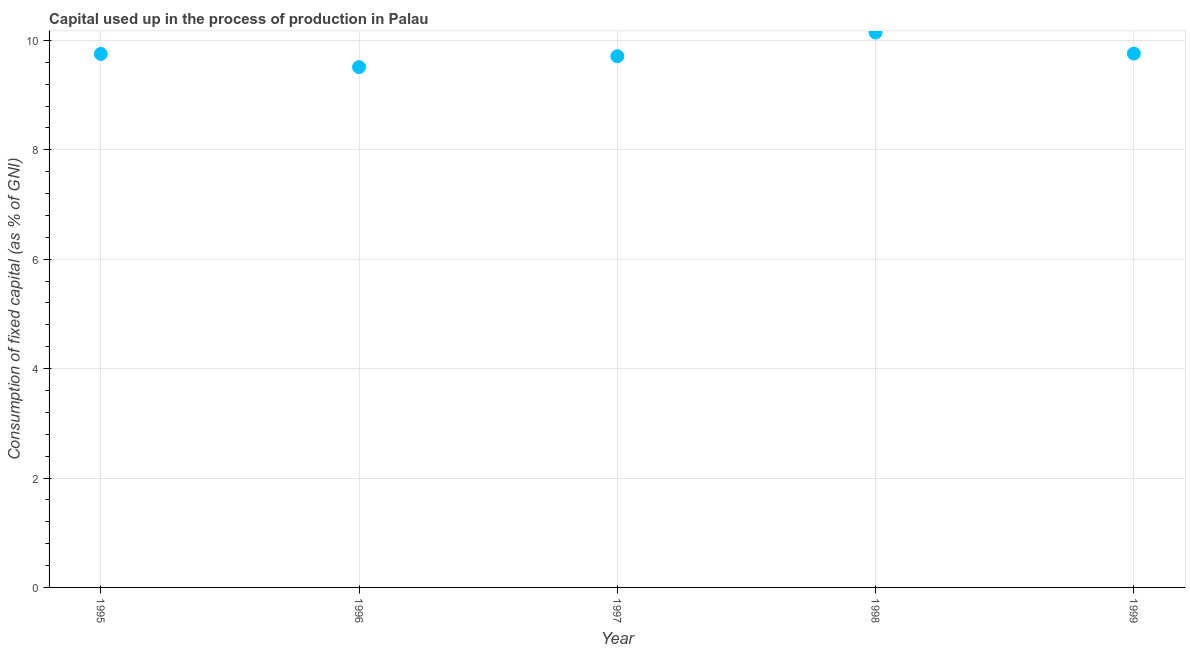What is the consumption of fixed capital in 1997?
Your response must be concise. 9.71. Across all years, what is the maximum consumption of fixed capital?
Your answer should be very brief. 10.14. Across all years, what is the minimum consumption of fixed capital?
Provide a short and direct response. 9.51. In which year was the consumption of fixed capital minimum?
Your answer should be very brief. 1996. What is the sum of the consumption of fixed capital?
Keep it short and to the point. 48.87. What is the difference between the consumption of fixed capital in 1995 and 1999?
Give a very brief answer. -0.01. What is the average consumption of fixed capital per year?
Offer a very short reply. 9.77. What is the median consumption of fixed capital?
Offer a terse response. 9.75. In how many years, is the consumption of fixed capital greater than 8.8 %?
Provide a succinct answer. 5. What is the ratio of the consumption of fixed capital in 1997 to that in 1999?
Make the answer very short. 1. Is the consumption of fixed capital in 1996 less than that in 1997?
Your answer should be very brief. Yes. What is the difference between the highest and the second highest consumption of fixed capital?
Give a very brief answer. 0.38. What is the difference between the highest and the lowest consumption of fixed capital?
Give a very brief answer. 0.63. Does the consumption of fixed capital monotonically increase over the years?
Provide a short and direct response. No. How many dotlines are there?
Offer a terse response. 1. How many years are there in the graph?
Your response must be concise. 5. What is the title of the graph?
Provide a short and direct response. Capital used up in the process of production in Palau. What is the label or title of the X-axis?
Ensure brevity in your answer.  Year. What is the label or title of the Y-axis?
Keep it short and to the point. Consumption of fixed capital (as % of GNI). What is the Consumption of fixed capital (as % of GNI) in 1995?
Keep it short and to the point. 9.75. What is the Consumption of fixed capital (as % of GNI) in 1996?
Your answer should be very brief. 9.51. What is the Consumption of fixed capital (as % of GNI) in 1997?
Offer a terse response. 9.71. What is the Consumption of fixed capital (as % of GNI) in 1998?
Offer a terse response. 10.14. What is the Consumption of fixed capital (as % of GNI) in 1999?
Make the answer very short. 9.76. What is the difference between the Consumption of fixed capital (as % of GNI) in 1995 and 1996?
Offer a very short reply. 0.24. What is the difference between the Consumption of fixed capital (as % of GNI) in 1995 and 1997?
Provide a succinct answer. 0.04. What is the difference between the Consumption of fixed capital (as % of GNI) in 1995 and 1998?
Your response must be concise. -0.39. What is the difference between the Consumption of fixed capital (as % of GNI) in 1995 and 1999?
Your answer should be very brief. -0.01. What is the difference between the Consumption of fixed capital (as % of GNI) in 1996 and 1997?
Keep it short and to the point. -0.2. What is the difference between the Consumption of fixed capital (as % of GNI) in 1996 and 1998?
Offer a very short reply. -0.63. What is the difference between the Consumption of fixed capital (as % of GNI) in 1996 and 1999?
Your answer should be compact. -0.25. What is the difference between the Consumption of fixed capital (as % of GNI) in 1997 and 1998?
Ensure brevity in your answer.  -0.43. What is the difference between the Consumption of fixed capital (as % of GNI) in 1997 and 1999?
Provide a short and direct response. -0.05. What is the difference between the Consumption of fixed capital (as % of GNI) in 1998 and 1999?
Your answer should be very brief. 0.38. What is the ratio of the Consumption of fixed capital (as % of GNI) in 1995 to that in 1997?
Make the answer very short. 1. What is the ratio of the Consumption of fixed capital (as % of GNI) in 1995 to that in 1998?
Your response must be concise. 0.96. What is the ratio of the Consumption of fixed capital (as % of GNI) in 1995 to that in 1999?
Your answer should be very brief. 1. What is the ratio of the Consumption of fixed capital (as % of GNI) in 1996 to that in 1998?
Provide a short and direct response. 0.94. What is the ratio of the Consumption of fixed capital (as % of GNI) in 1998 to that in 1999?
Provide a short and direct response. 1.04. 